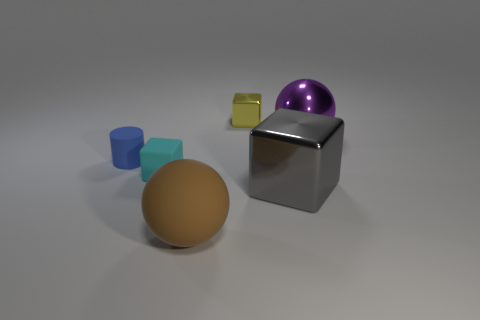Considering the arrangement of the objects, what could this image be used to illustrate? This image could be used to illustrate concepts in geometry, such as various 3D shapes and their properties. It could also demonstrate the effects of different material finishes on light reflection and shadow casting, useful in a physics or art context to discuss light interactions with surfaces. 